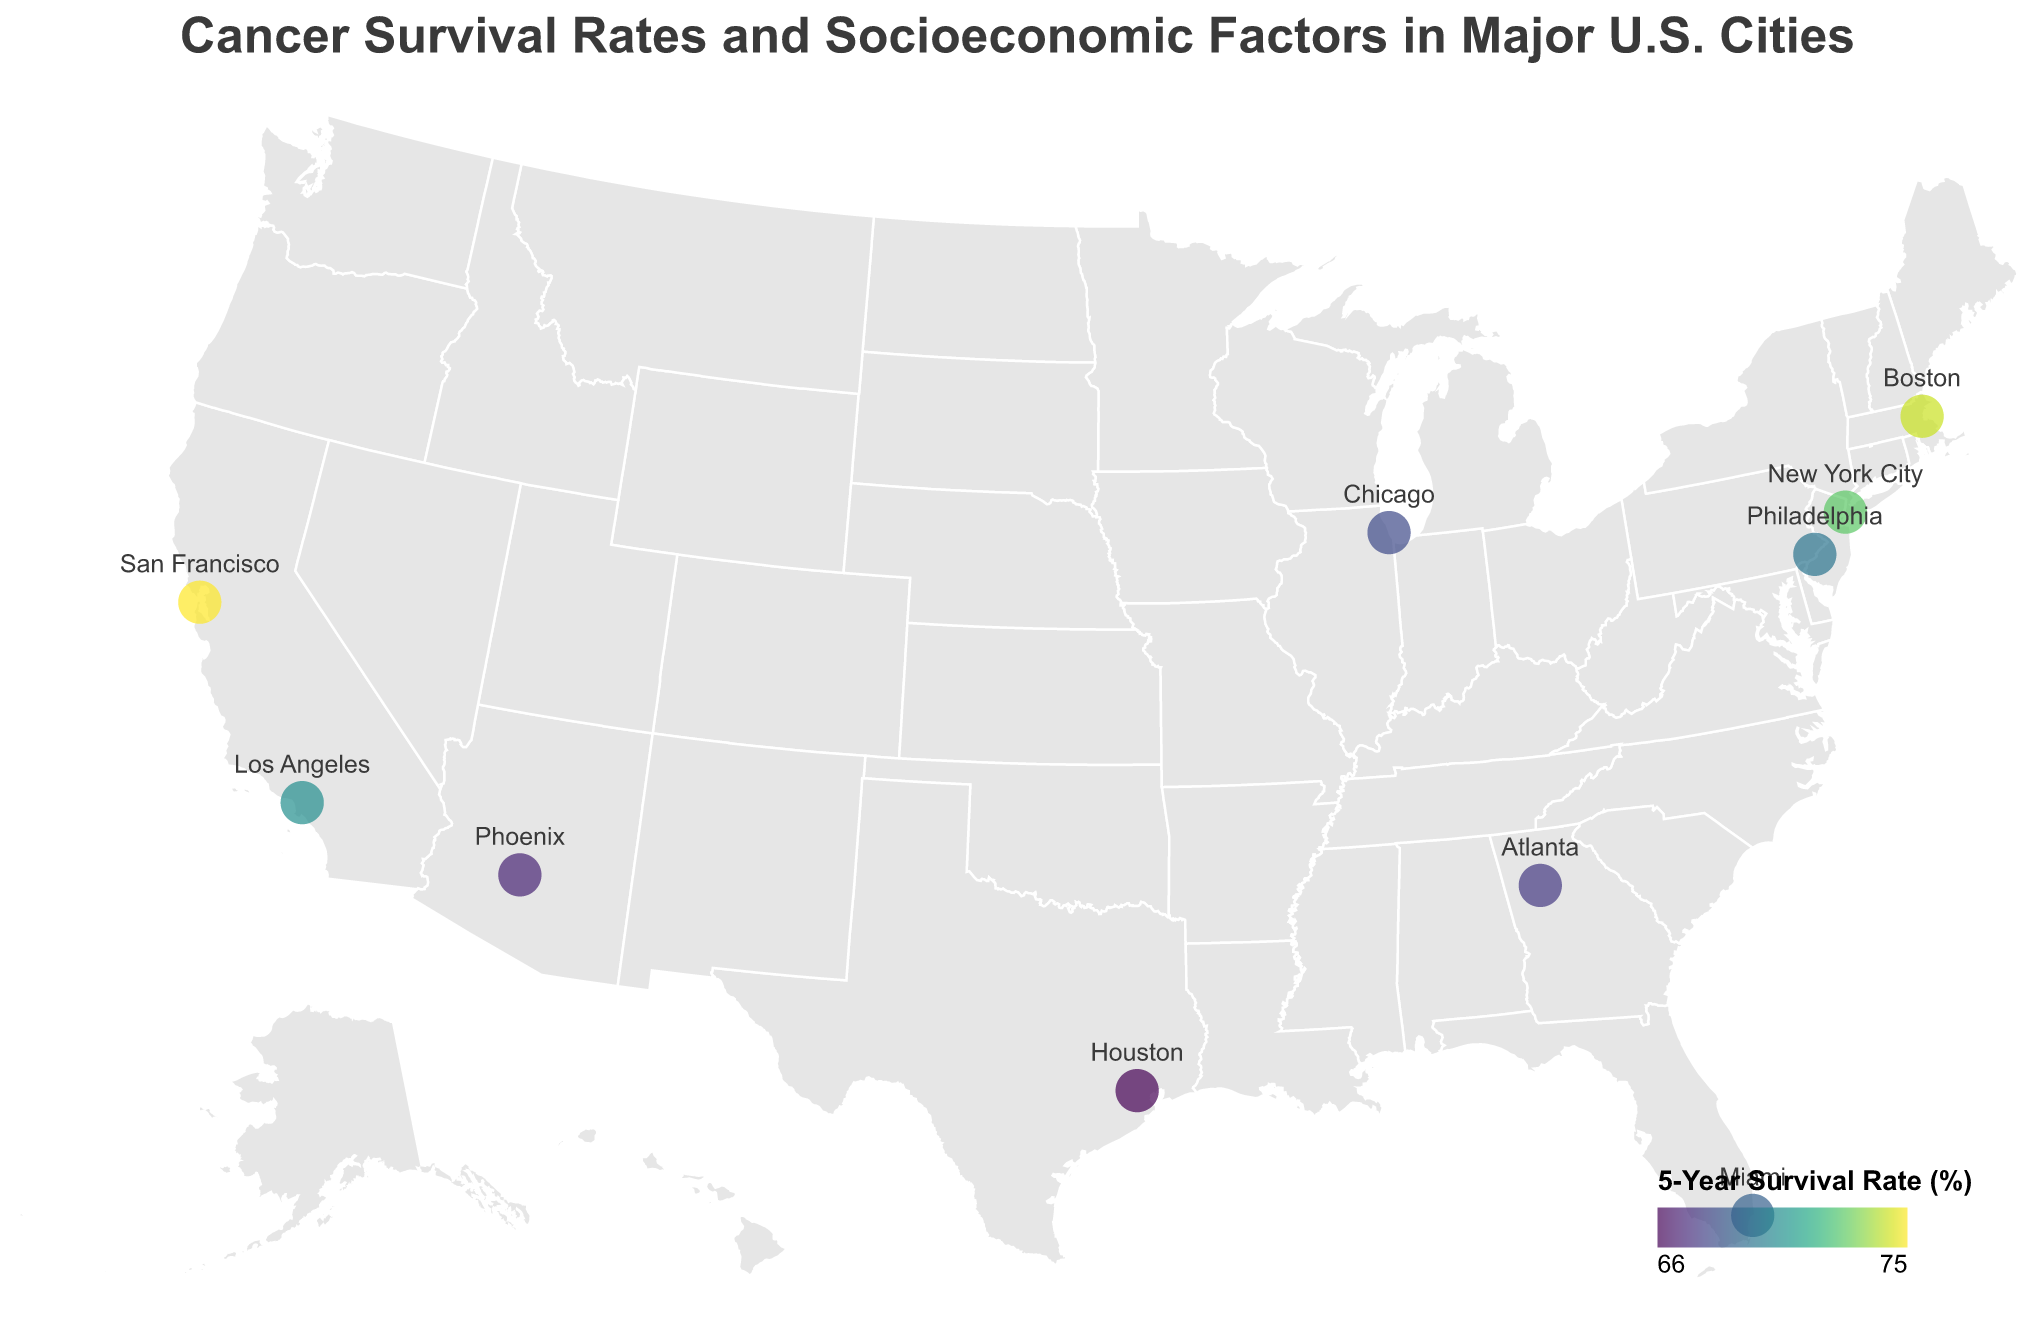What is the title of the map? The title of the map is usually found at the top and describes the overall content of the figure. Look at the top center part of the figure.
Answer: "Cancer Survival Rates and Socioeconomic Factors in Major U.S. Cities" Which city has the highest 5-year survival rate? Identify which data point has the highest value in the legend for the 5-Year Survival Rate, indicated by the color scale.
Answer: San Francisco, CA Which city has the lowest median household income? Find the data point with the lowest value for the Median Household Income stated in the tooltip.
Answer: Philadelphia, PA What is the general trend between uninsured rates and 5-year survival rates? Compare the color gradient linked to the 5-Year Survival Rate across different points with their respective uninsured rates mentioned in the tooltip. Cities with lower uninsured rates generally have higher survival rates.
Answer: Lower uninsured rates are associated with higher survival rates Which city has the least uninsured rate and how does it compare to its 5-year survival rate? Identify the city with the least uninsured rate from the tooltips, and then check its corresponding survival rate on the color scale.
Answer: Boston, MA with a 3.8% uninsured rate; its 5-year survival rate is 73.8% Is there a correlation between median household income and 5-year survival rates? Look at the pattern of survival rates and median household income across the data points. Higher median incomes are generally associated with higher survival rates.
Answer: Higher median household incomes are generally associated with higher survival rates Which cities have a 5-year survival rate below 70%? Identify the points on the map with survival rates below 70% by using the color scale and tooltips.
Answer: Miami, FL; Chicago, IL; Houston, TX; Phoenix, AZ; Atlanta, GA How do the survival rates in Miami compare to New York City? Look at the colors representing the 5-Year Survival Rates for both cities and verify the exact values in the tooltips. Miami's survival rate is 68.5%, and New York City's rate is 72.3%.
Answer: New York City's survival rate is higher than Miami's Which cancer center is present in Houston and what is the city's survival rate? Refer to Houston’s data point in the tooltip to find the cancer center and the survival rate.
Answer: MD Anderson Cancer Center; 65.9% Does Boston have a higher 5-year survival rate than Atlanta? Contrast the survival rates by checking the color indicators and specific values in the tooltips. Boston's survival rate is 73.8% while Atlanta's is 67.3%.
Answer: Yes, Boston has a higher 5-year survival rate than Atlanta 